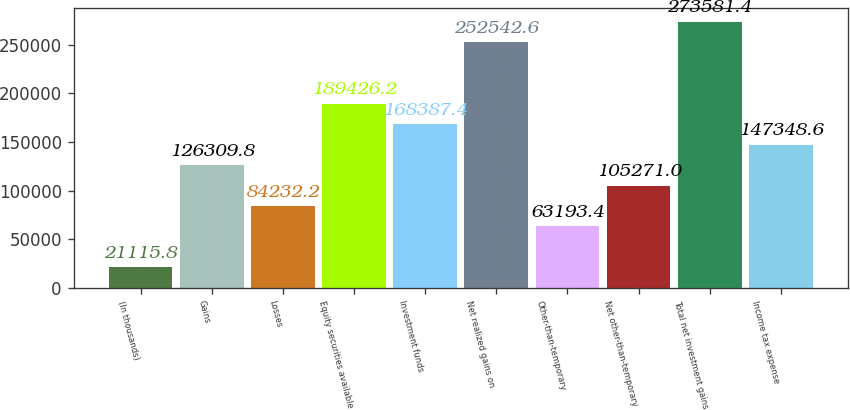Convert chart to OTSL. <chart><loc_0><loc_0><loc_500><loc_500><bar_chart><fcel>(In thousands)<fcel>Gains<fcel>Losses<fcel>Equity securities available<fcel>Investment funds<fcel>Net realized gains on<fcel>Other-than-temporary<fcel>Net other-than-temporary<fcel>Total net investment gains<fcel>Income tax expense<nl><fcel>21115.8<fcel>126310<fcel>84232.2<fcel>189426<fcel>168387<fcel>252543<fcel>63193.4<fcel>105271<fcel>273581<fcel>147349<nl></chart> 